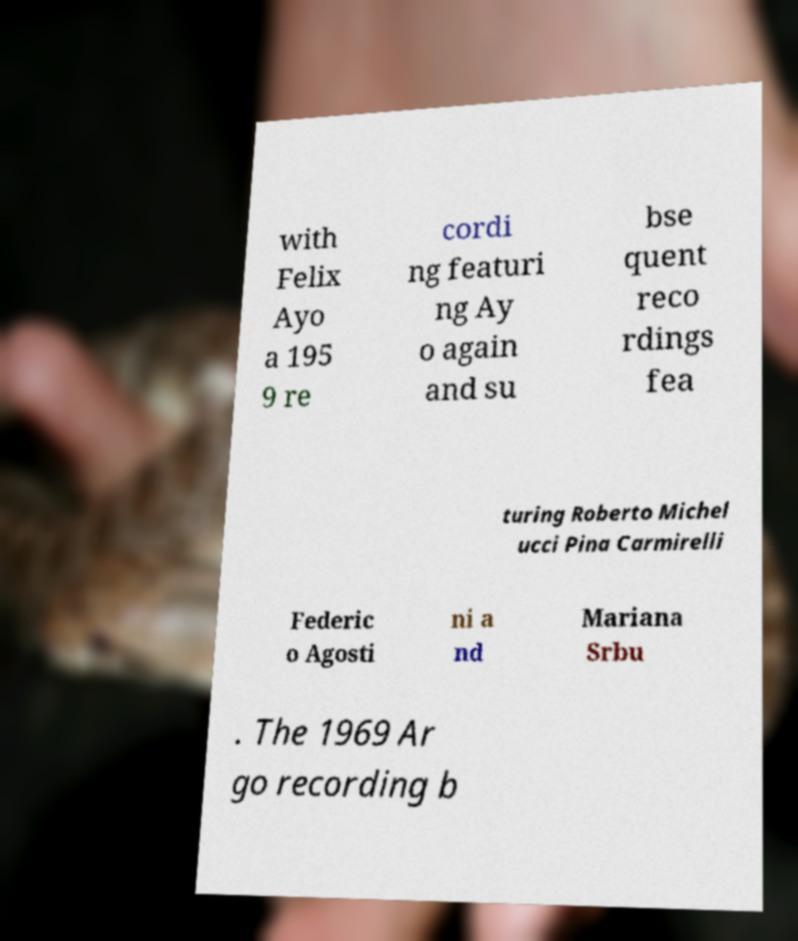What messages or text are displayed in this image? I need them in a readable, typed format. with Felix Ayo a 195 9 re cordi ng featuri ng Ay o again and su bse quent reco rdings fea turing Roberto Michel ucci Pina Carmirelli Federic o Agosti ni a nd Mariana Srbu . The 1969 Ar go recording b 